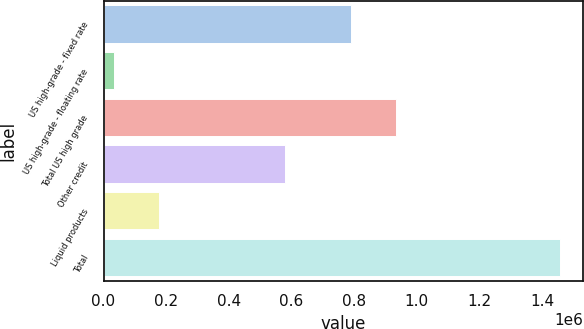Convert chart. <chart><loc_0><loc_0><loc_500><loc_500><bar_chart><fcel>US high-grade - fixed rate<fcel>US high-grade - floating rate<fcel>Total US high grade<fcel>Other credit<fcel>Liquid products<fcel>Total<nl><fcel>791194<fcel>33839<fcel>933643<fcel>579912<fcel>176288<fcel>1.45833e+06<nl></chart> 